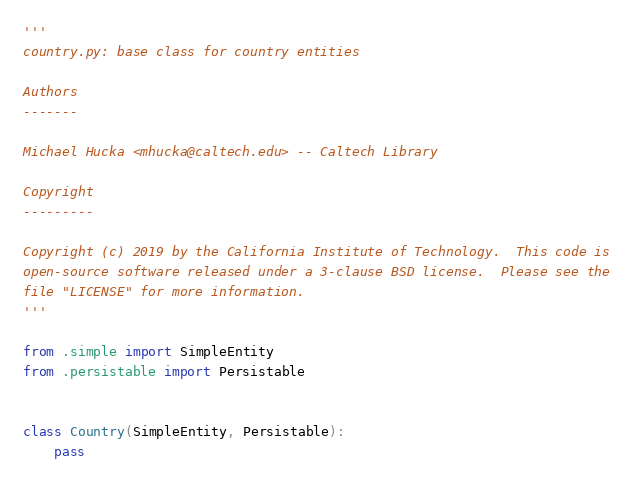<code> <loc_0><loc_0><loc_500><loc_500><_Python_>'''
country.py: base class for country entities

Authors
-------

Michael Hucka <mhucka@caltech.edu> -- Caltech Library

Copyright
---------

Copyright (c) 2019 by the California Institute of Technology.  This code is
open-source software released under a 3-clause BSD license.  Please see the
file "LICENSE" for more information.
'''

from .simple import SimpleEntity
from .persistable import Persistable


class Country(SimpleEntity, Persistable):
    pass
</code> 